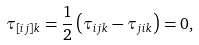<formula> <loc_0><loc_0><loc_500><loc_500>\tau _ { [ i j ] k } = \frac { 1 } { 2 } \left ( \tau _ { i j k } - \tau _ { j i k } \right ) = 0 ,</formula> 